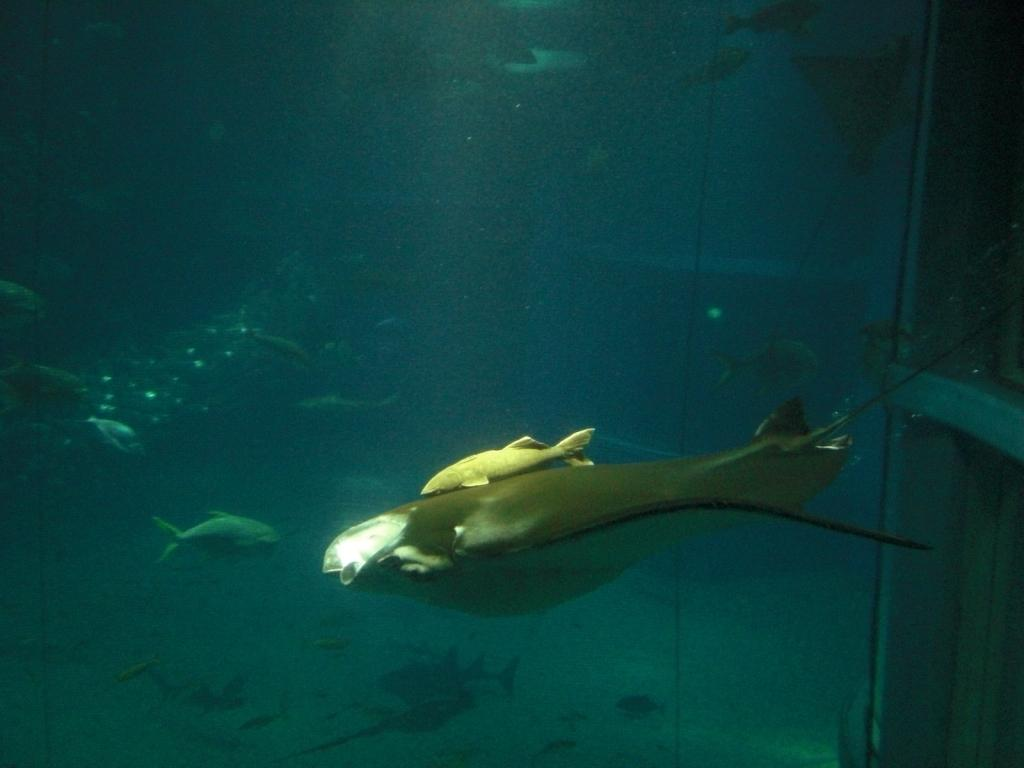What type of animals can be seen in the water in the image? There are fish in the water in the image. How many birds are in the flock flying over the water in the image? There are no birds or flocks present in the image; it features fish in the water. 